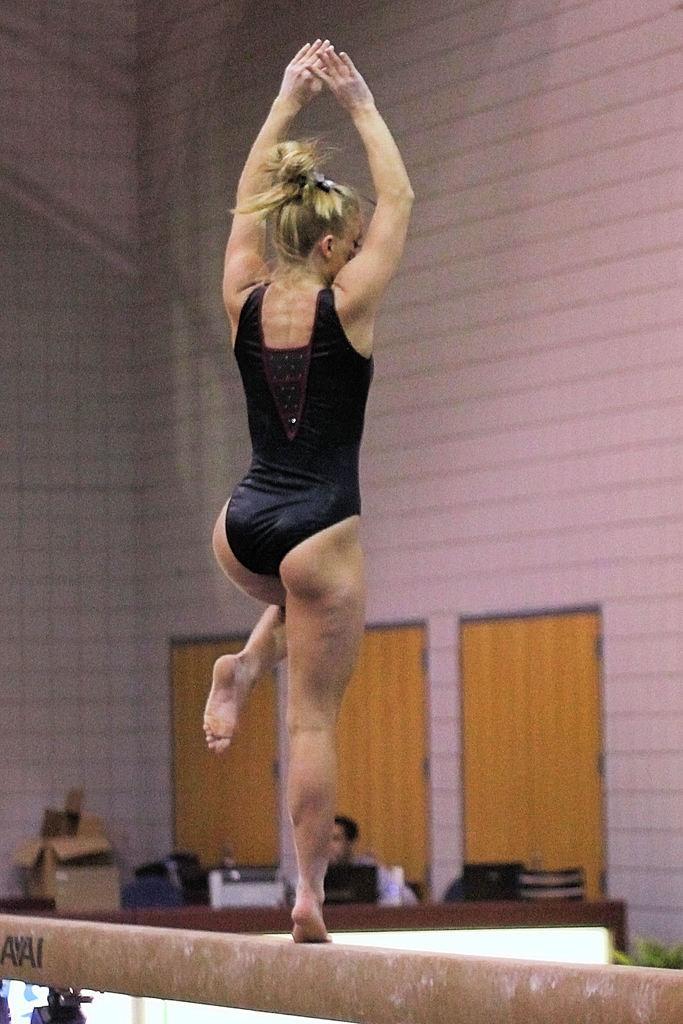Can you describe this image briefly? Here in this picture we can see a woman standing on a pole and performing gymnast and in front of her we can see a person sitting with a table in front of him with number of things present on it in blurry manner and we can also see doors present. 